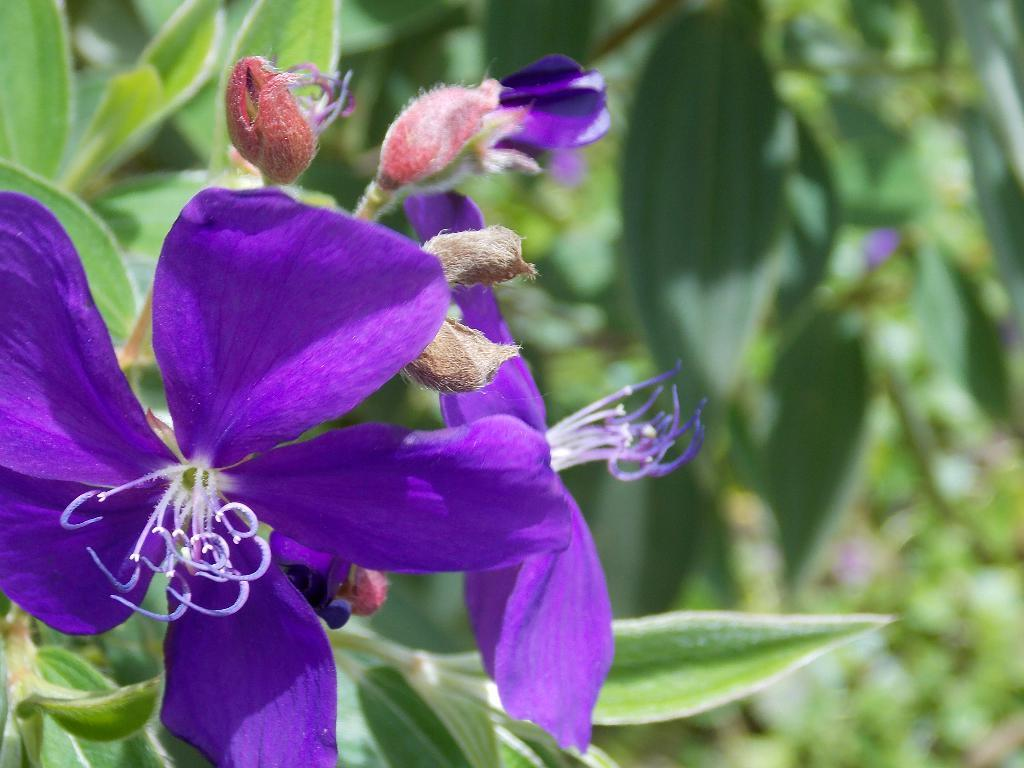What color are the flowers in the image? The flowers in the image are violet. What type of plant do the flowers belong to? The flowers belong to a plant. Can you describe the background of the image? The background of the image is blurred. What else can be seen in the background besides the blurred area? Leaves are present in the background of the image. Can you see a feather in the mouth of the dog in the image? There is no dog or feather present in the image. 